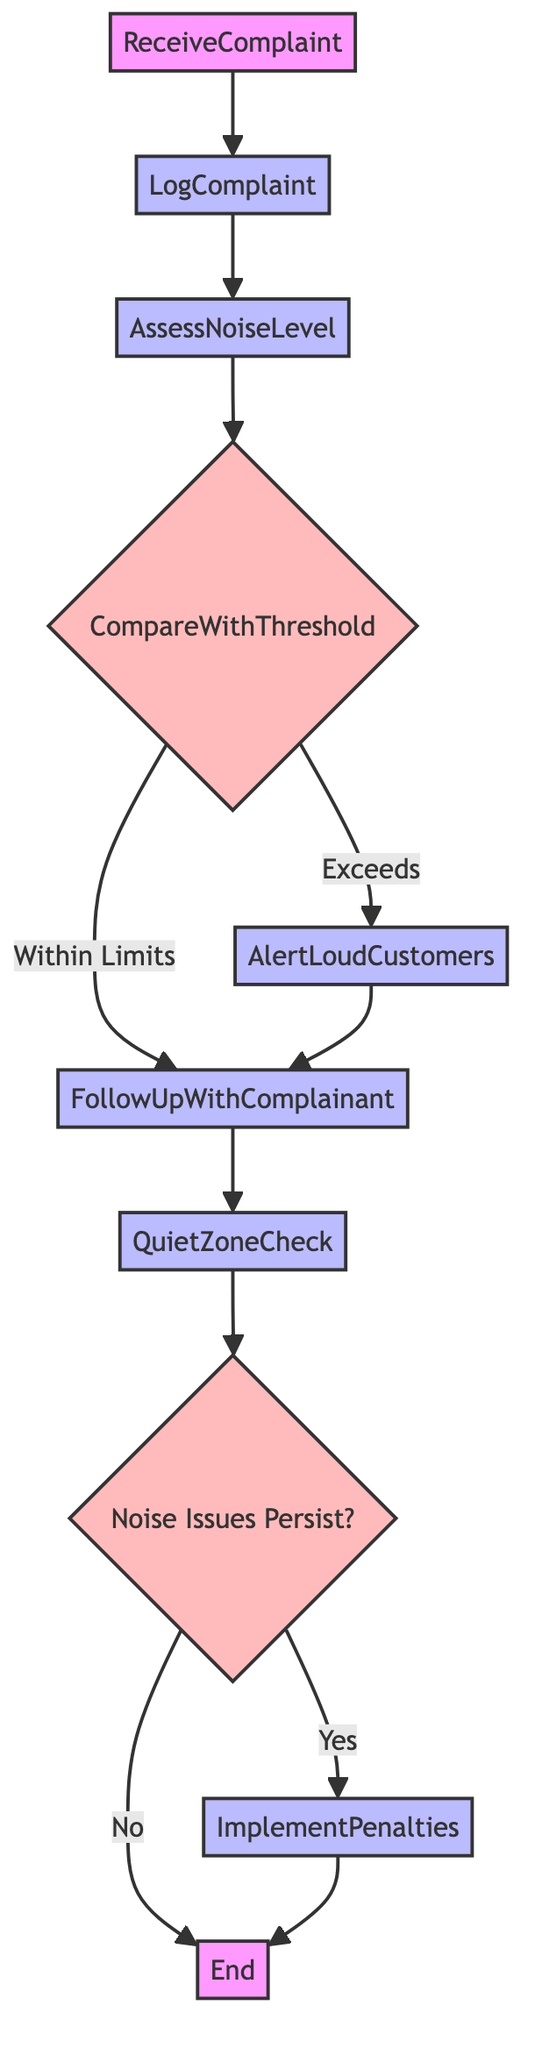What's the first step in the function? The first step listed in the flowchart is "ReceiveComplaint." It is the starting point of the process where a customer submits a noise complaint.
Answer: ReceiveComplaint How many processes are there in total? Reviewing the diagram, all steps except for the decision steps are processes. There are six processes: LogComplaint, AssessNoiseLevel, AlertLoudCustomers, FollowUpWithComplainant, QuietZoneCheck, and ImplementPenalties.
Answer: Six What action is taken if the noise level exceeds the threshold? According to the diagram, if the noise level exceeds the threshold, the staff will "AlertLoudCustomers" to lower their volume.
Answer: AlertLoudCustomers What happens after assessing the noise level? After assessing the noise level, the next action is to "CompareWithThreshold" where the staff compares the assessed noise level with the predefined acceptable noise threshold.
Answer: CompareWithThreshold If noise issues persist, what is implemented? If noise issues persist, "ImplementPenalties" are put in place, which may include actions like restricted Wi-Fi access for repeat offenders.
Answer: ImplementPenalties What is the action following "AlertLoudCustomers"? After alerting loud customers, the next action in the flowchart is to "FollowUpWithComplainant" to ensure their concerns are addressed.
Answer: FollowUpWithComplainant What decision is made after the "QuietZoneCheck"? The decision made after "QuietZoneCheck" is whether "Noise Issues Persist?" This determines the next course of action based on whether there are continuing complaints.
Answer: Noise Issues Persist? What is the outcome if noise issues do not persist? If noise issues do not persist, the flowchart indicates that the process ends with "End," concluding the management of the complaint process.
Answer: End 